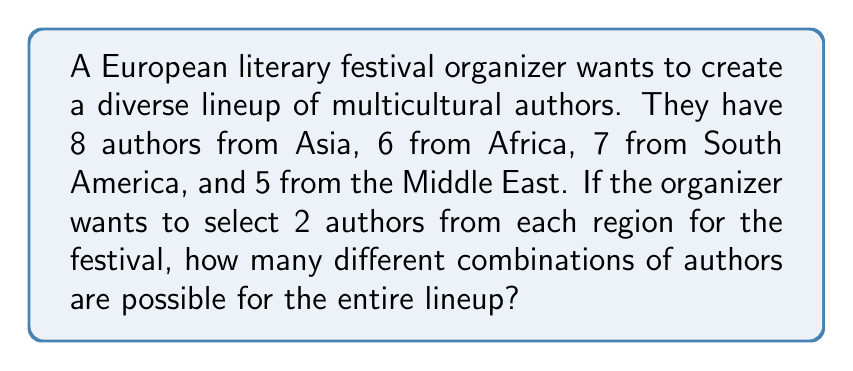Could you help me with this problem? Let's approach this step-by-step:

1) We need to select 2 authors from each of the 4 regions. This is a combination problem for each region.

2) For each region, we use the combination formula:
   $C(n,r) = \frac{n!}{r!(n-r)!}$
   where $n$ is the total number of authors from a region and $r$ is the number we're selecting (2 in this case).

3) Let's calculate for each region:

   Asia: $C(8,2) = \frac{8!}{2!(8-2)!} = \frac{8!}{2!6!} = 28$

   Africa: $C(6,2) = \frac{6!}{2!(6-2)!} = \frac{6!}{2!4!} = 15$

   South America: $C(7,2) = \frac{7!}{2!(7-2)!} = \frac{7!}{2!5!} = 21$

   Middle East: $C(5,2) = \frac{5!}{2!(5-2)!} = \frac{5!}{2!3!} = 10$

4) Now, we have the number of ways to choose 2 authors from each region. To find the total number of possible lineups, we multiply these together (using the multiplication principle of counting).

5) The final calculation is:

   $28 \times 15 \times 21 \times 10 = 88,200$

Therefore, there are 88,200 different possible combinations for the entire lineup.
Answer: 88,200 